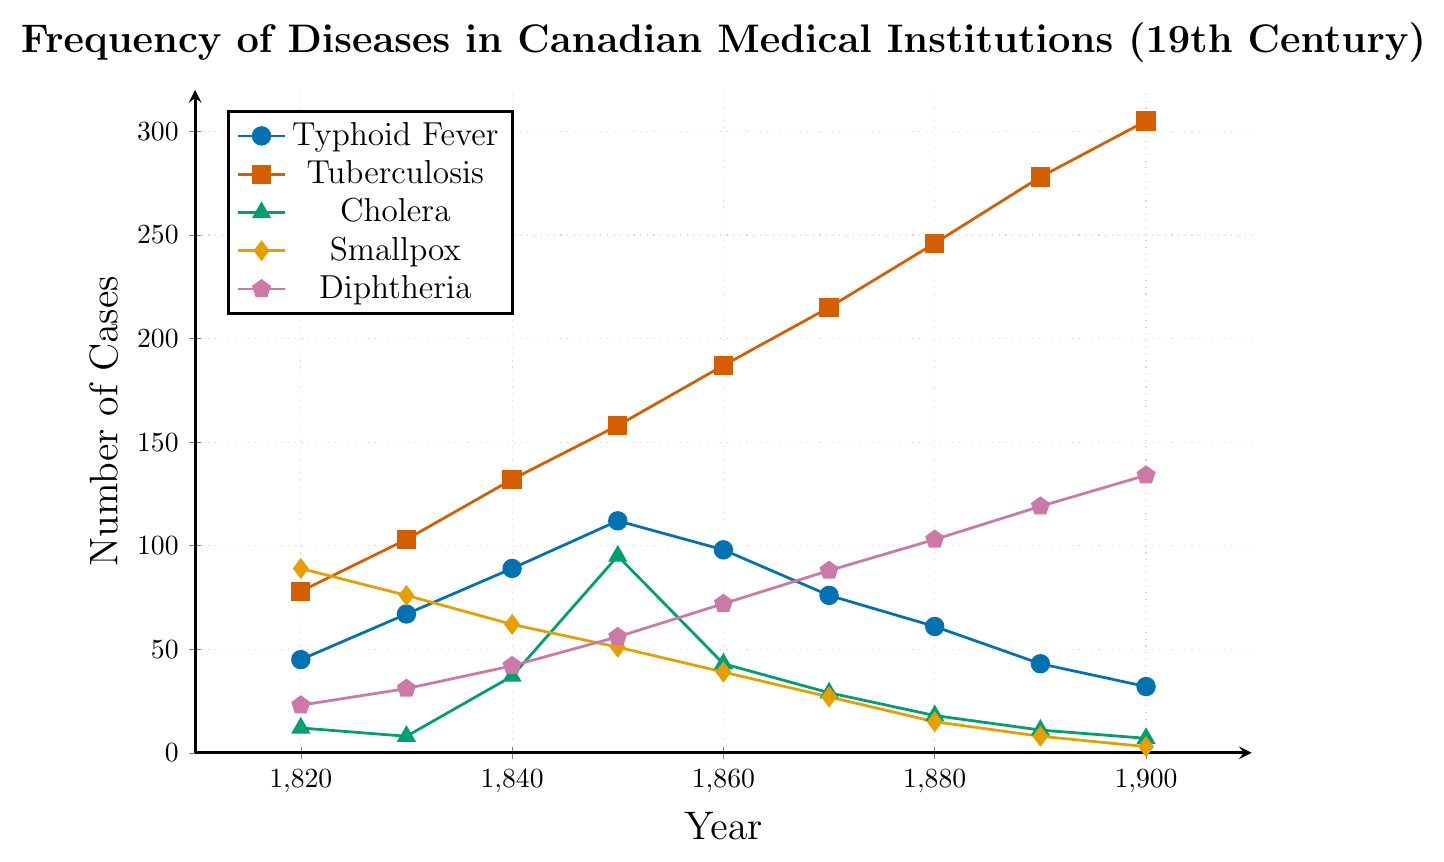What year saw the highest number of tuberculosis cases? By observing the graph, we can see that the height of the line representing tuberculosis cases is highest in the year 1900.
Answer: 1900 Between which years did typhoid fever cases decrease the most significantly? By comparing the slopes of the typhoid fever line, the most significant drop is between 1850 and 1860.
Answer: 1850 and 1860 Which disease saw the most consistent increase throughout the century? Observing the graph, tuberculosis shows a steady and constant increase from 1820 to 1900 without any drops.
Answer: Tuberculosis In 1860, how many more cases of tuberculosis were there compared to cholera? In 1860, there were 187 cases of tuberculosis and 43 cases of cholera. The difference is 187 - 43 = 144.
Answer: 144 What is the sum of smallpox cases in 1840 and diphtheria cases in 1890? In 1840, there were 62 cases of smallpox and in 1890, there were 119 cases of diphtheria. The sum is 62 + 119 = 181.
Answer: 181 Which disease had the highest number of cases in 1830? By observing the figures for 1830, tuberculosis had the highest number of cases, with 103 cases.
Answer: Tuberculosis How did cholera cases change from 1840 to 1850? By comparing the graph, cholera cases increased from 37 in 1840 to 95 in 1850.
Answer: Increased What is the average number of typhoid fever cases over the entire century? Sum up the cases of typhoid fever from each year: 45 + 67 + 89 + 112 + 98 + 76 + 61 + 43 + 32 = 623. There are 9 data points, so the average is 623 / 9 ≈ 69.22.
Answer: 69.22 In what year did diphtheria cases exceed 100 for the first time? By looking at the plot, diphtheria cases first exceeded 100 in the year 1880.
Answer: 1880 